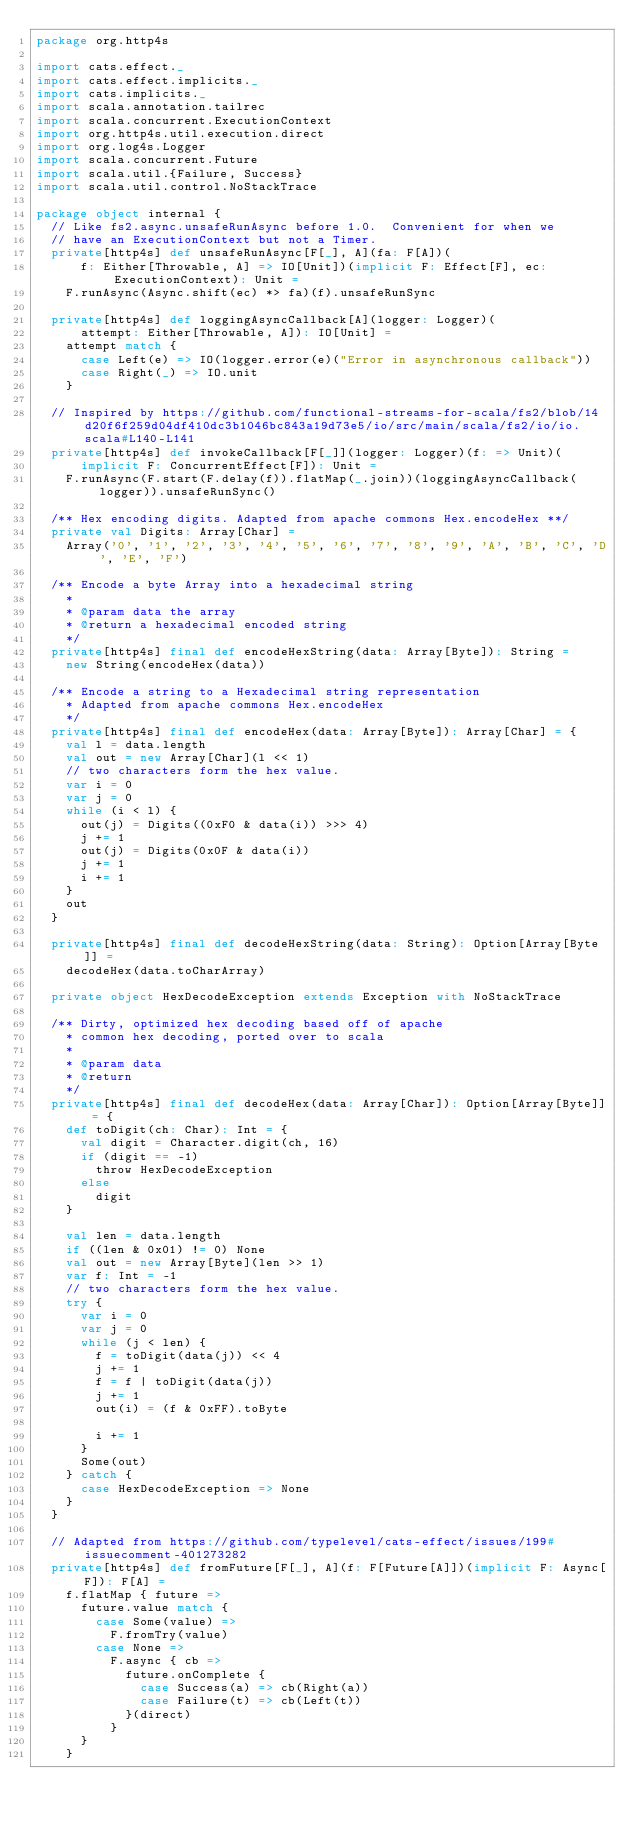Convert code to text. <code><loc_0><loc_0><loc_500><loc_500><_Scala_>package org.http4s

import cats.effect._
import cats.effect.implicits._
import cats.implicits._
import scala.annotation.tailrec
import scala.concurrent.ExecutionContext
import org.http4s.util.execution.direct
import org.log4s.Logger
import scala.concurrent.Future
import scala.util.{Failure, Success}
import scala.util.control.NoStackTrace

package object internal {
  // Like fs2.async.unsafeRunAsync before 1.0.  Convenient for when we
  // have an ExecutionContext but not a Timer.
  private[http4s] def unsafeRunAsync[F[_], A](fa: F[A])(
      f: Either[Throwable, A] => IO[Unit])(implicit F: Effect[F], ec: ExecutionContext): Unit =
    F.runAsync(Async.shift(ec) *> fa)(f).unsafeRunSync

  private[http4s] def loggingAsyncCallback[A](logger: Logger)(
      attempt: Either[Throwable, A]): IO[Unit] =
    attempt match {
      case Left(e) => IO(logger.error(e)("Error in asynchronous callback"))
      case Right(_) => IO.unit
    }

  // Inspired by https://github.com/functional-streams-for-scala/fs2/blob/14d20f6f259d04df410dc3b1046bc843a19d73e5/io/src/main/scala/fs2/io/io.scala#L140-L141
  private[http4s] def invokeCallback[F[_]](logger: Logger)(f: => Unit)(
      implicit F: ConcurrentEffect[F]): Unit =
    F.runAsync(F.start(F.delay(f)).flatMap(_.join))(loggingAsyncCallback(logger)).unsafeRunSync()

  /** Hex encoding digits. Adapted from apache commons Hex.encodeHex **/
  private val Digits: Array[Char] =
    Array('0', '1', '2', '3', '4', '5', '6', '7', '8', '9', 'A', 'B', 'C', 'D', 'E', 'F')

  /** Encode a byte Array into a hexadecimal string
    *
    * @param data the array
    * @return a hexadecimal encoded string
    */
  private[http4s] final def encodeHexString(data: Array[Byte]): String =
    new String(encodeHex(data))

  /** Encode a string to a Hexadecimal string representation
    * Adapted from apache commons Hex.encodeHex
    */
  private[http4s] final def encodeHex(data: Array[Byte]): Array[Char] = {
    val l = data.length
    val out = new Array[Char](l << 1)
    // two characters form the hex value.
    var i = 0
    var j = 0
    while (i < l) {
      out(j) = Digits((0xF0 & data(i)) >>> 4)
      j += 1
      out(j) = Digits(0x0F & data(i))
      j += 1
      i += 1
    }
    out
  }

  private[http4s] final def decodeHexString(data: String): Option[Array[Byte]] =
    decodeHex(data.toCharArray)

  private object HexDecodeException extends Exception with NoStackTrace

  /** Dirty, optimized hex decoding based off of apache
    * common hex decoding, ported over to scala
    *
    * @param data
    * @return
    */
  private[http4s] final def decodeHex(data: Array[Char]): Option[Array[Byte]] = {
    def toDigit(ch: Char): Int = {
      val digit = Character.digit(ch, 16)
      if (digit == -1)
        throw HexDecodeException
      else
        digit
    }

    val len = data.length
    if ((len & 0x01) != 0) None
    val out = new Array[Byte](len >> 1)
    var f: Int = -1
    // two characters form the hex value.
    try {
      var i = 0
      var j = 0
      while (j < len) {
        f = toDigit(data(j)) << 4
        j += 1
        f = f | toDigit(data(j))
        j += 1
        out(i) = (f & 0xFF).toByte

        i += 1
      }
      Some(out)
    } catch {
      case HexDecodeException => None
    }
  }

  // Adapted from https://github.com/typelevel/cats-effect/issues/199#issuecomment-401273282
  private[http4s] def fromFuture[F[_], A](f: F[Future[A]])(implicit F: Async[F]): F[A] =
    f.flatMap { future =>
      future.value match {
        case Some(value) =>
          F.fromTry(value)
        case None =>
          F.async { cb =>
            future.onComplete {
              case Success(a) => cb(Right(a))
              case Failure(t) => cb(Left(t))
            }(direct)
          }
      }
    }
</code> 